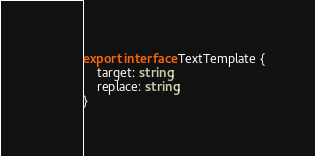Convert code to text. <code><loc_0><loc_0><loc_500><loc_500><_TypeScript_>export interface TextTemplate {
    target: string;
    replace: string;
}</code> 